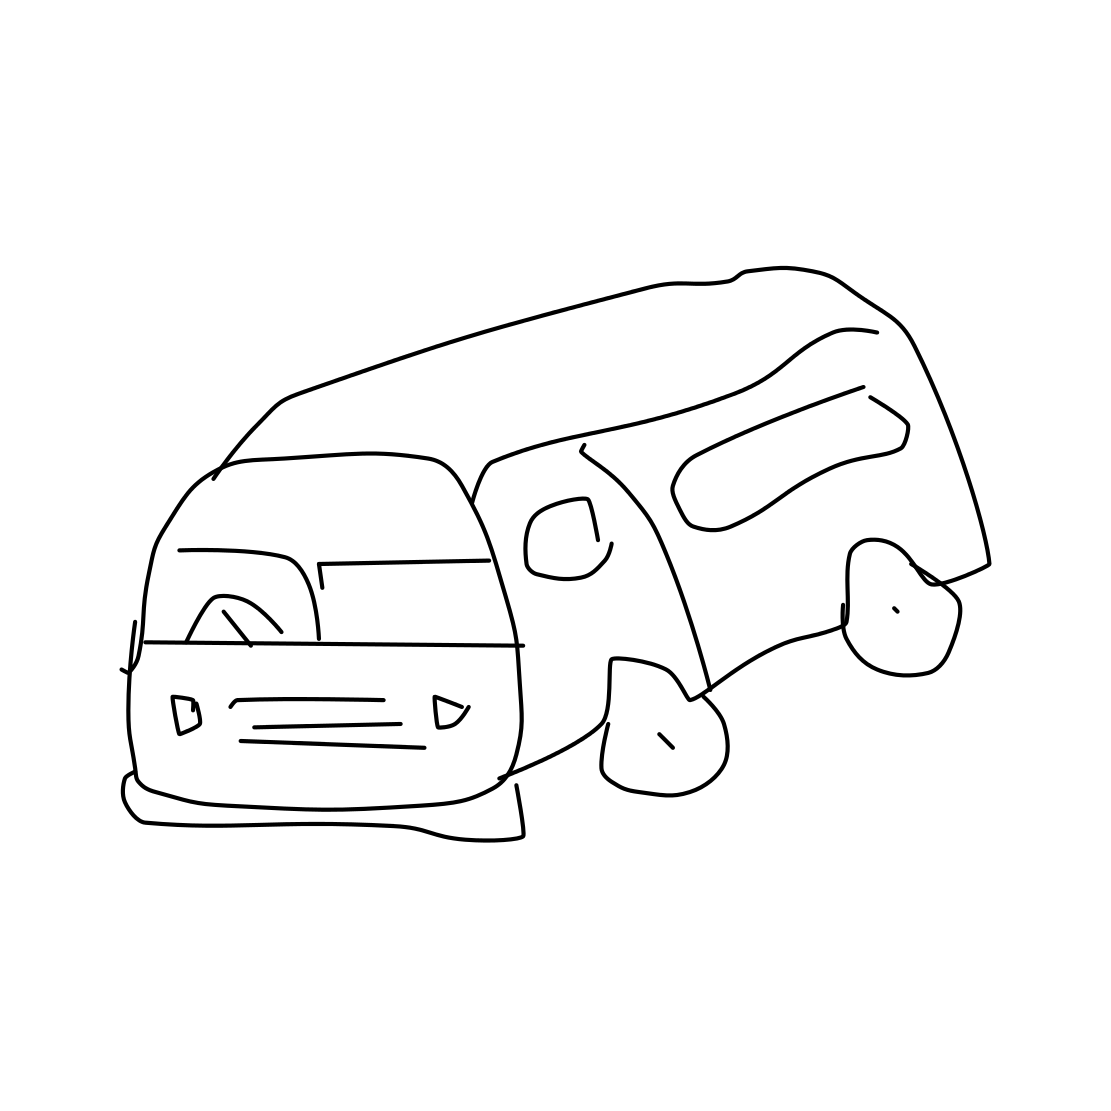Is there a sketchy van in the picture? Yes 